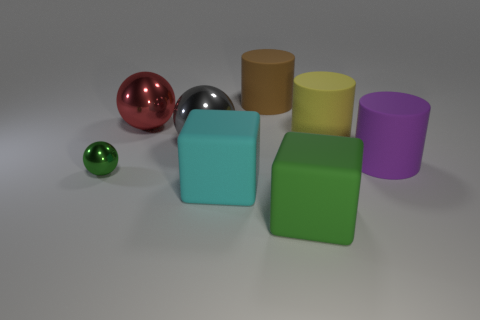Add 1 big yellow cylinders. How many objects exist? 9 Subtract all cylinders. How many objects are left? 5 Subtract all large matte things. Subtract all large brown matte cylinders. How many objects are left? 2 Add 1 brown cylinders. How many brown cylinders are left? 2 Add 3 big cyan cylinders. How many big cyan cylinders exist? 3 Subtract 0 blue spheres. How many objects are left? 8 